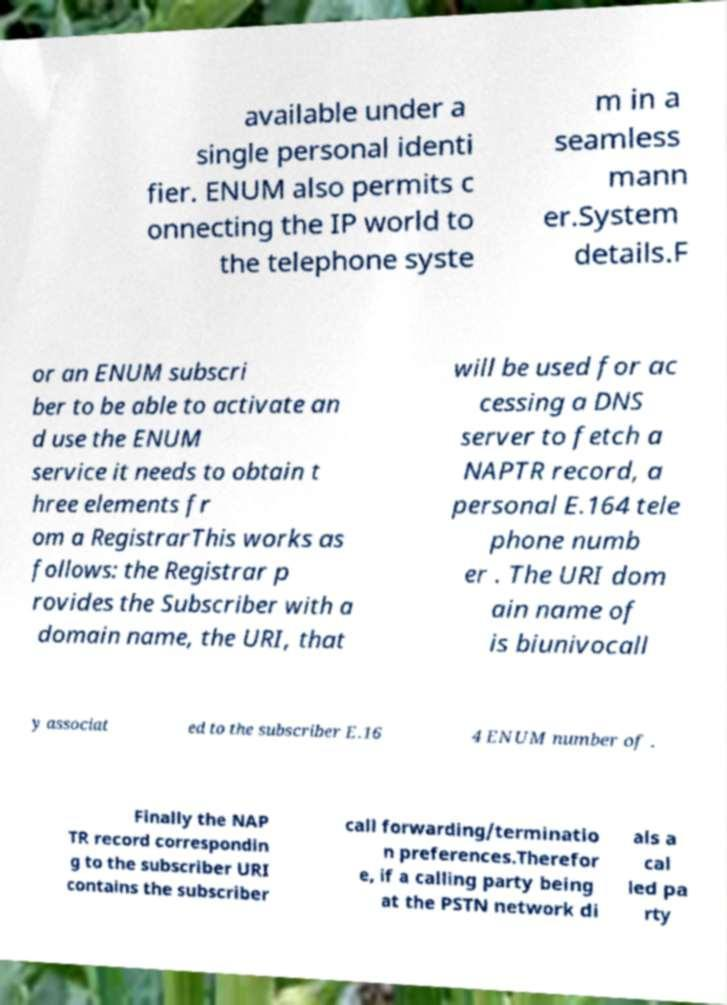Can you accurately transcribe the text from the provided image for me? available under a single personal identi fier. ENUM also permits c onnecting the IP world to the telephone syste m in a seamless mann er.System details.F or an ENUM subscri ber to be able to activate an d use the ENUM service it needs to obtain t hree elements fr om a RegistrarThis works as follows: the Registrar p rovides the Subscriber with a domain name, the URI, that will be used for ac cessing a DNS server to fetch a NAPTR record, a personal E.164 tele phone numb er . The URI dom ain name of is biunivocall y associat ed to the subscriber E.16 4 ENUM number of . Finally the NAP TR record correspondin g to the subscriber URI contains the subscriber call forwarding/terminatio n preferences.Therefor e, if a calling party being at the PSTN network di als a cal led pa rty 